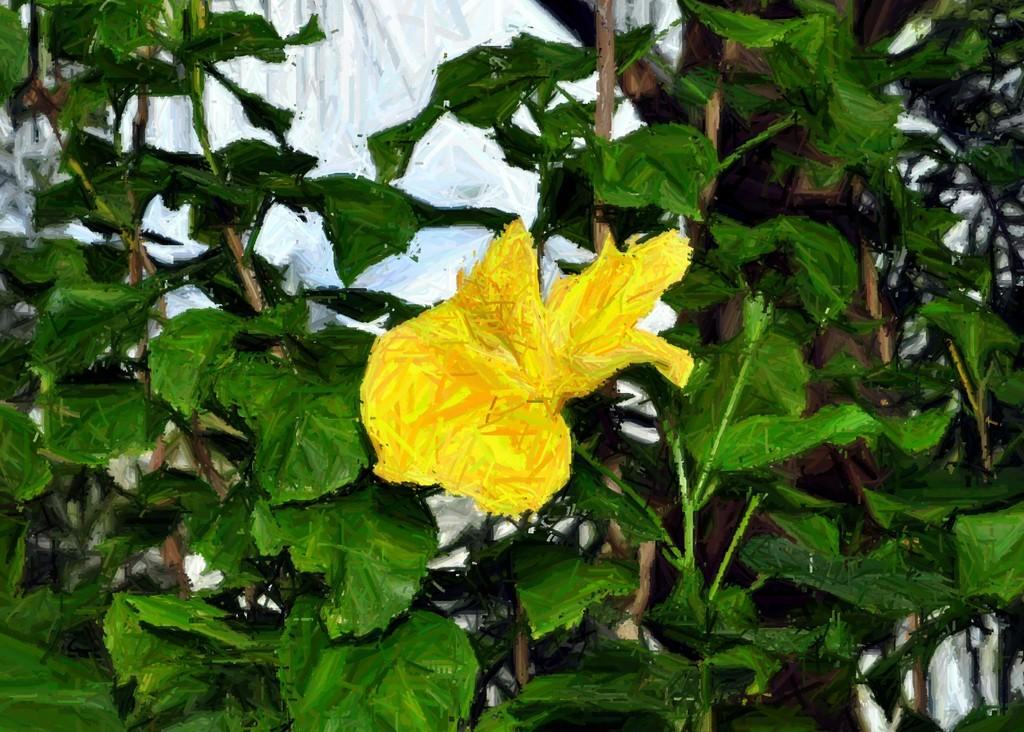What is the main subject of the picture? The main subject of the picture is a printed image. What is located in front of the printed image? There is a yellow flower in front of the image. What type of vegetation is associated with the flower? There are green leaves associated with the flower. Can you tell me how many pots are visible in the image? There is no pot present in the image. What type of ocean can be seen in the background of the image? There is no ocean visible in the image. 